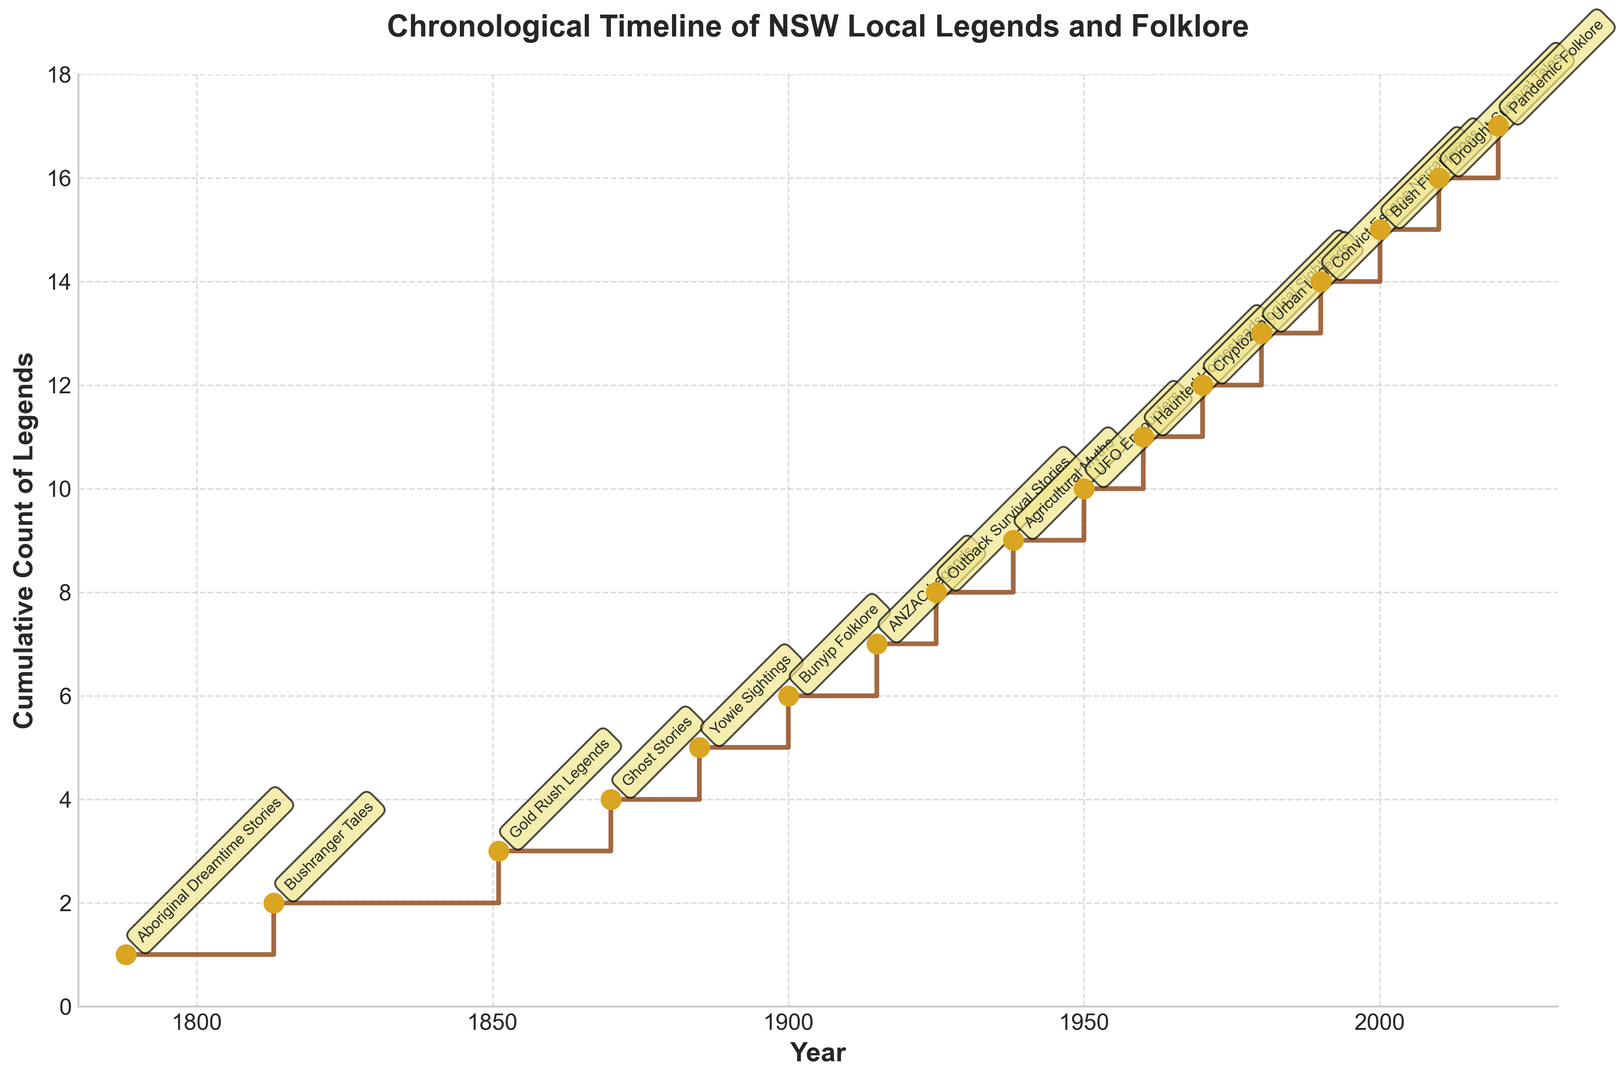How many legends are noted before 1900? By observing the cumulative count values before the year 1900 (1788, 1813, 1851, and 1870), we count 1, 2, 3, and 4 respectively. Adding these values, the total is 1+2+3+4=10.
Answer: 10 Which theme appears at the midpoint of the plot timeline? The midpoint year between 1788 and 2020 is roughly 1904. Looking near this year on the plot, the themes surrounding it are 'Yowie Sightings' (1885) and 'Bunyip Folklore' (1900). However, the closest to the midpoint is 'Bunyip Folklore'.
Answer: Bunyip Folklore What is the first legend after 2000? By looking at the years after 2000, we notice themes listed for 2010 and 2020, and the first theme listed after 2000 is 'Drought Survival Tales' in 2010.
Answer: Drought Survival Tales By how many legends does the count increase between the 'Bush Fire Heroes' and 'Pandemic Folklore'? The cumulative count value for 'Bush Fire Heroes' in 2000 is 15, and for 'Pandemic Folklore' in 2020, it is 17. The difference between these values is 17-15=2.
Answer: 2 What is the cumulative legend count in the year of 'ANZAC Legends'? From the plot, 'ANZAC Legends' occurred in 1915, with a corresponding cumulative count value of 7.
Answer: 7 Which theme had the least number of legends by their respective year? Observing the cumulative counts at each specified year, 'Aboriginal Dreamtime Stories' in 1788 had the least number with a count of 1.
Answer: Aboriginal Dreamtime Stories Which themes reached a cumulative count of 8 and 12, respectively? Checking the cumulative count column, an entry of 8 is seen in 1925 for 'Outback Survival Stories', and a count of 12 is seen in 1970 for 'Cryptozoological Sightings'.
Answer: Outback Survival Stories, Cryptozoological Sightings Between which years did the legends' cumulative count grow the most? Examining the differences in cumulative count between each consecutive year, the largest increase, which is from 1 to 2, happened between 1788 (1) to 1813 (2) and there is an increase of 1 in 1938 (9) to 1950 (10).
Answer: 1788 to 1813 and 1938 to 1950 What is the theme at cumulative count 11? From the plot, the theme at cumulative count 11 is associated with the year 1960, which is 'Haunted Homesteads'.
Answer: Haunted Homesteads 